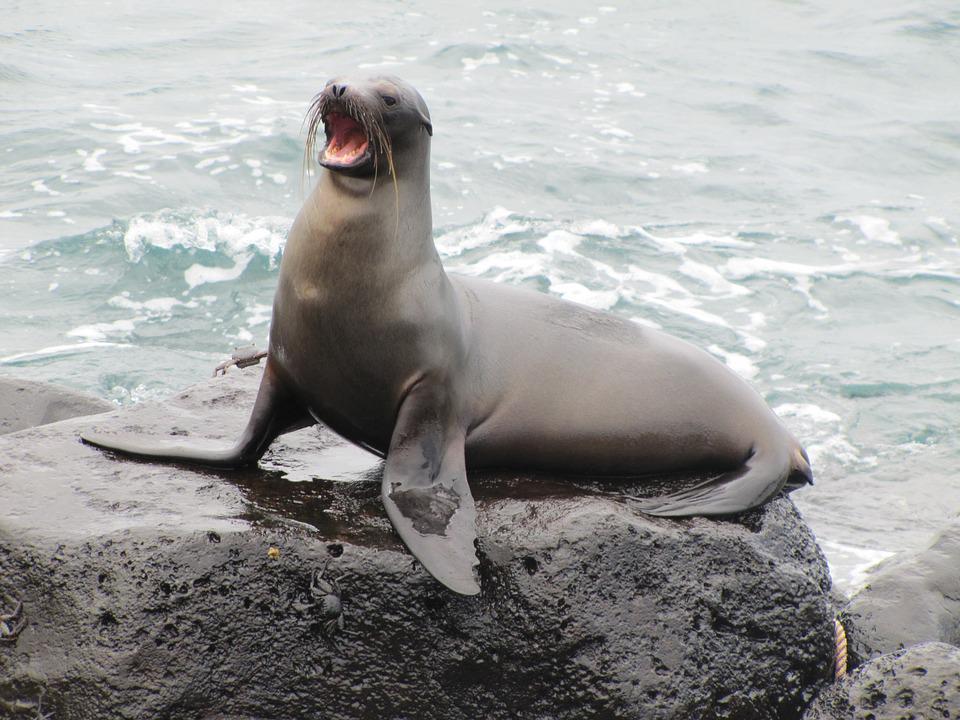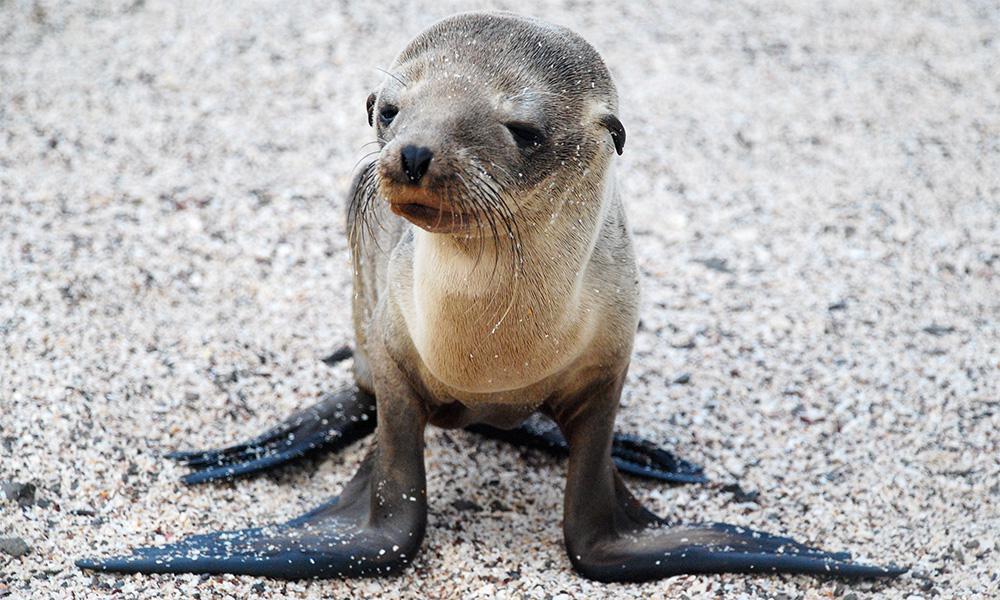The first image is the image on the left, the second image is the image on the right. Analyze the images presented: Is the assertion "One seal has its mouth open, and another one does not." valid? Answer yes or no. Yes. The first image is the image on the left, the second image is the image on the right. Evaluate the accuracy of this statement regarding the images: "A single seal is standing on top of a rock with its mouth open.". Is it true? Answer yes or no. Yes. 